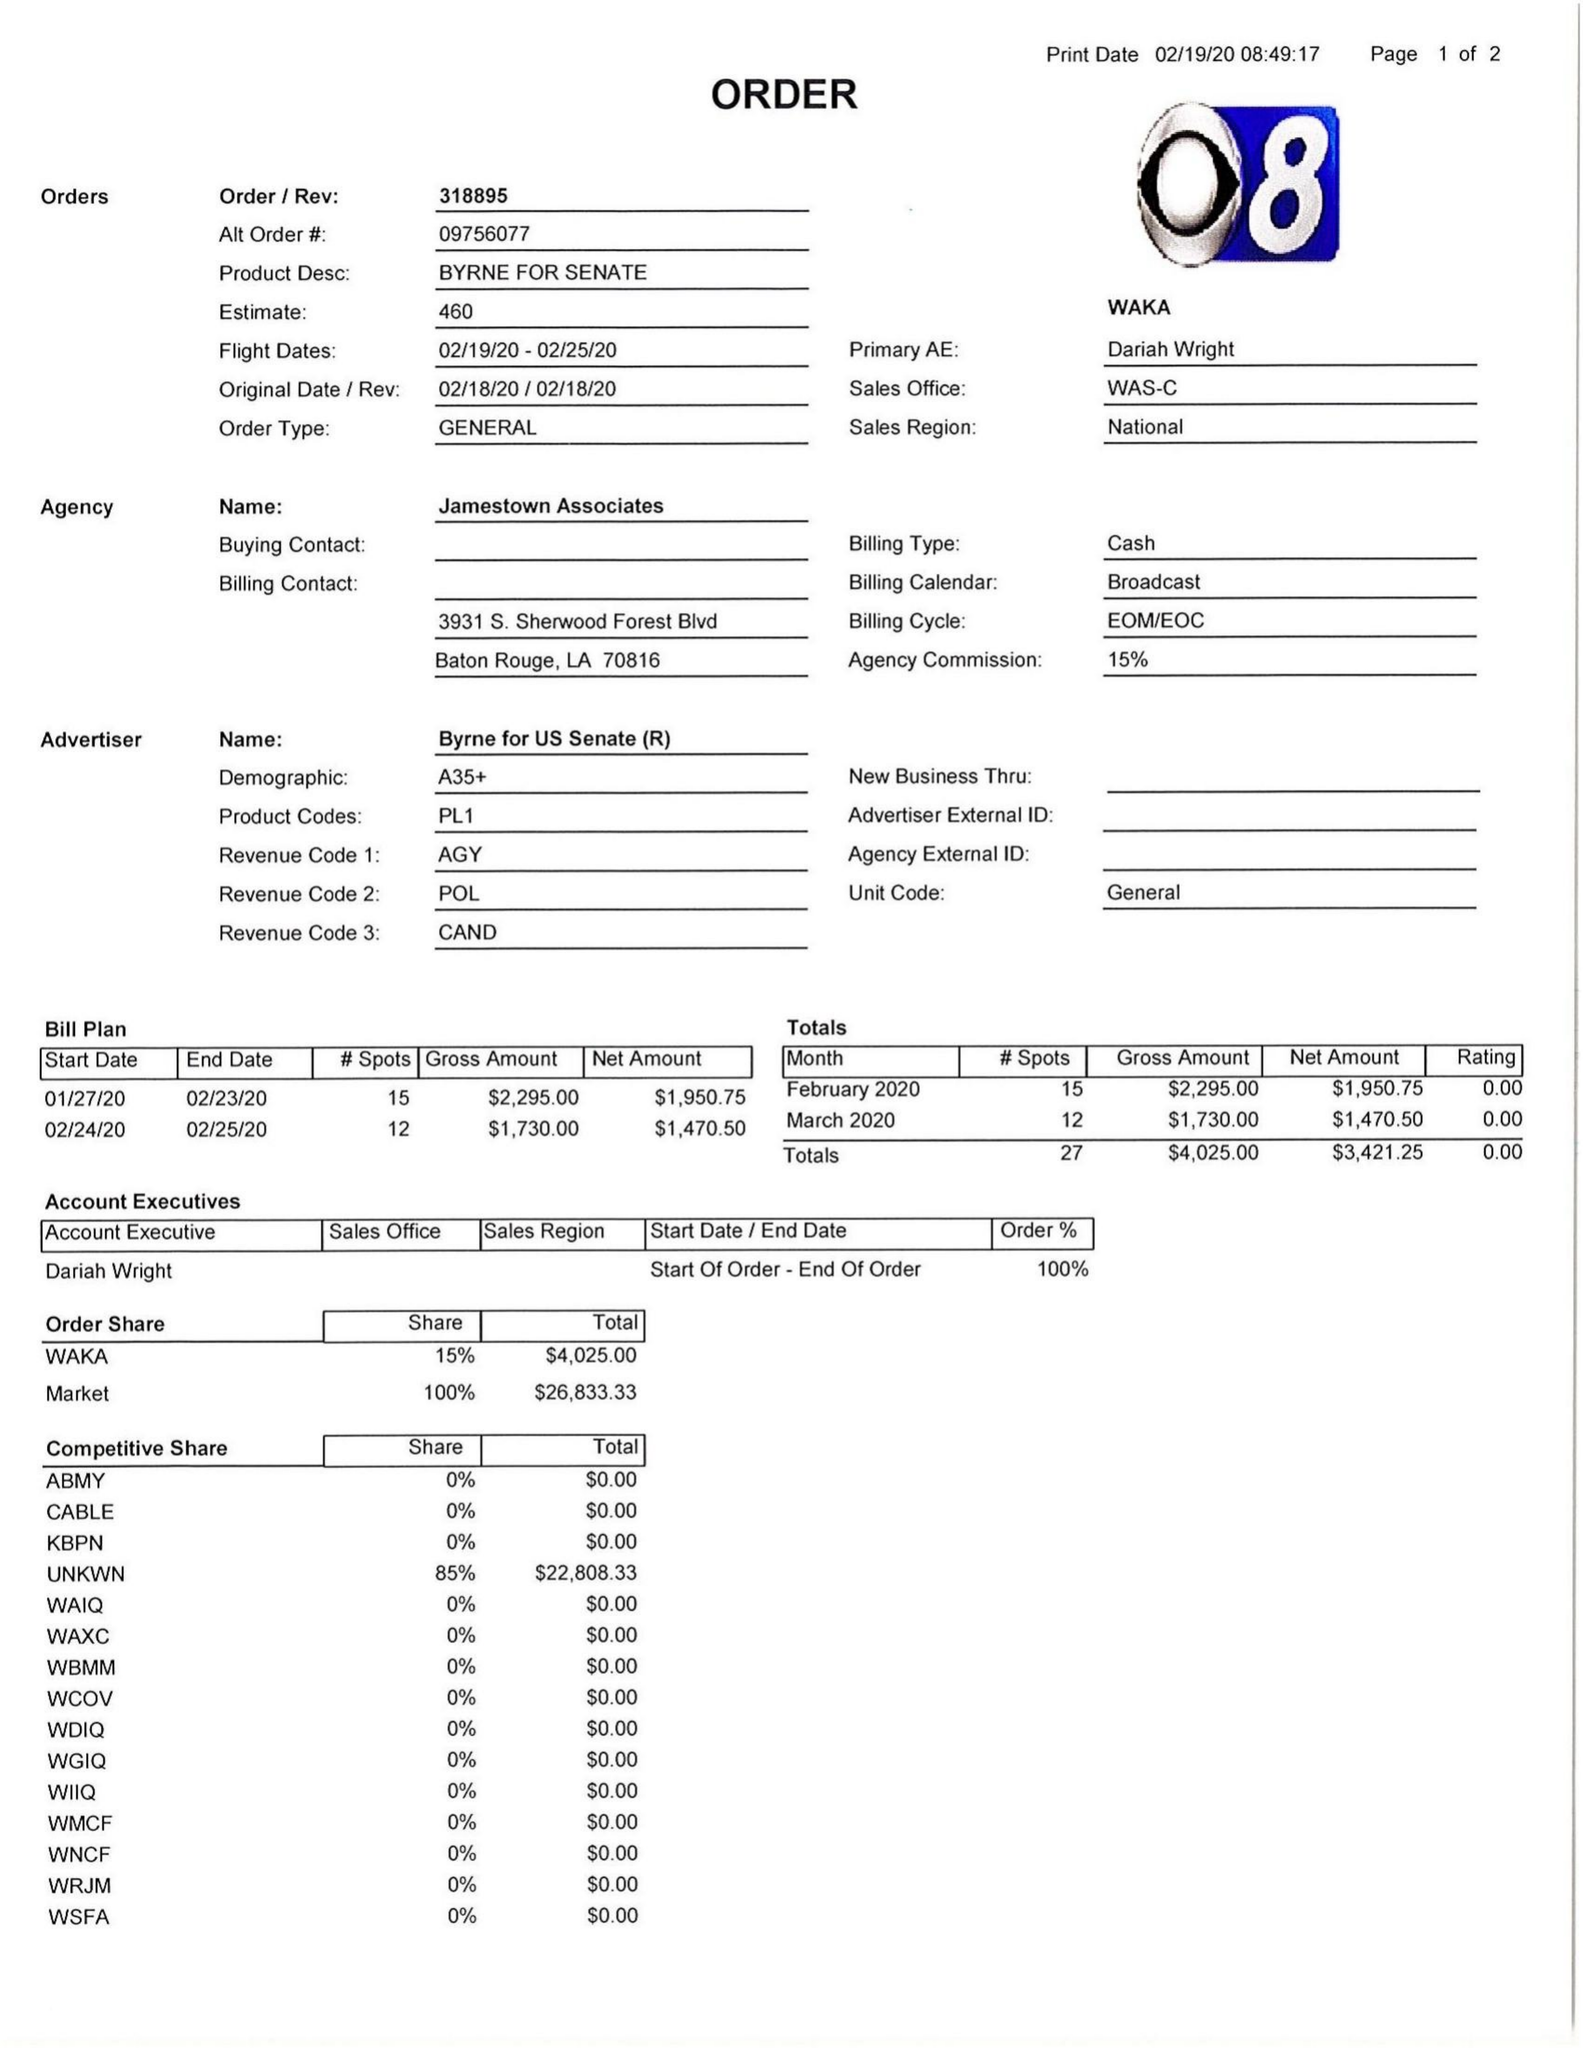What is the value for the gross_amount?
Answer the question using a single word or phrase. 4025.00 